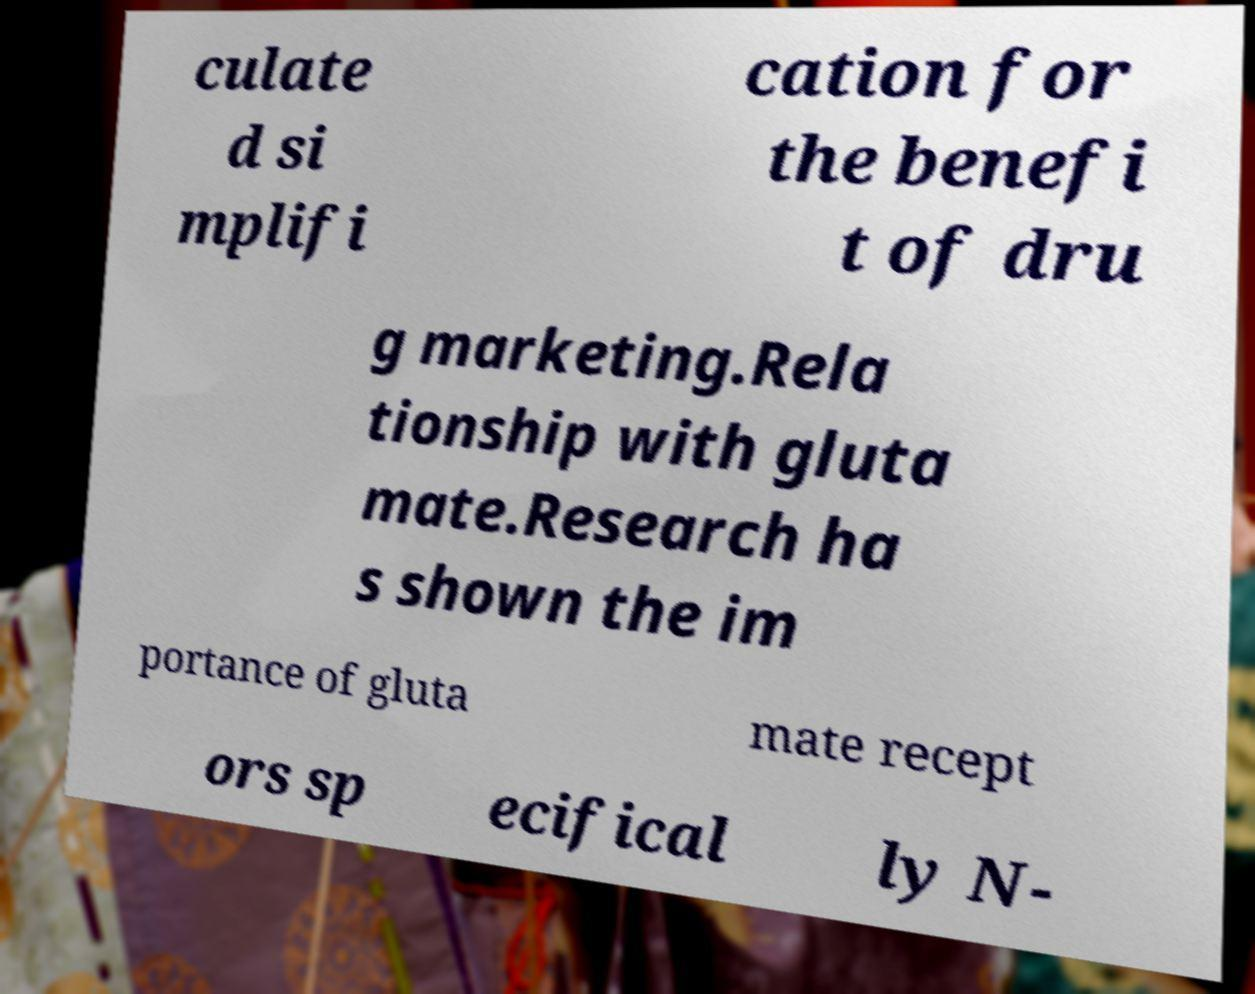Can you accurately transcribe the text from the provided image for me? culate d si mplifi cation for the benefi t of dru g marketing.Rela tionship with gluta mate.Research ha s shown the im portance of gluta mate recept ors sp ecifical ly N- 